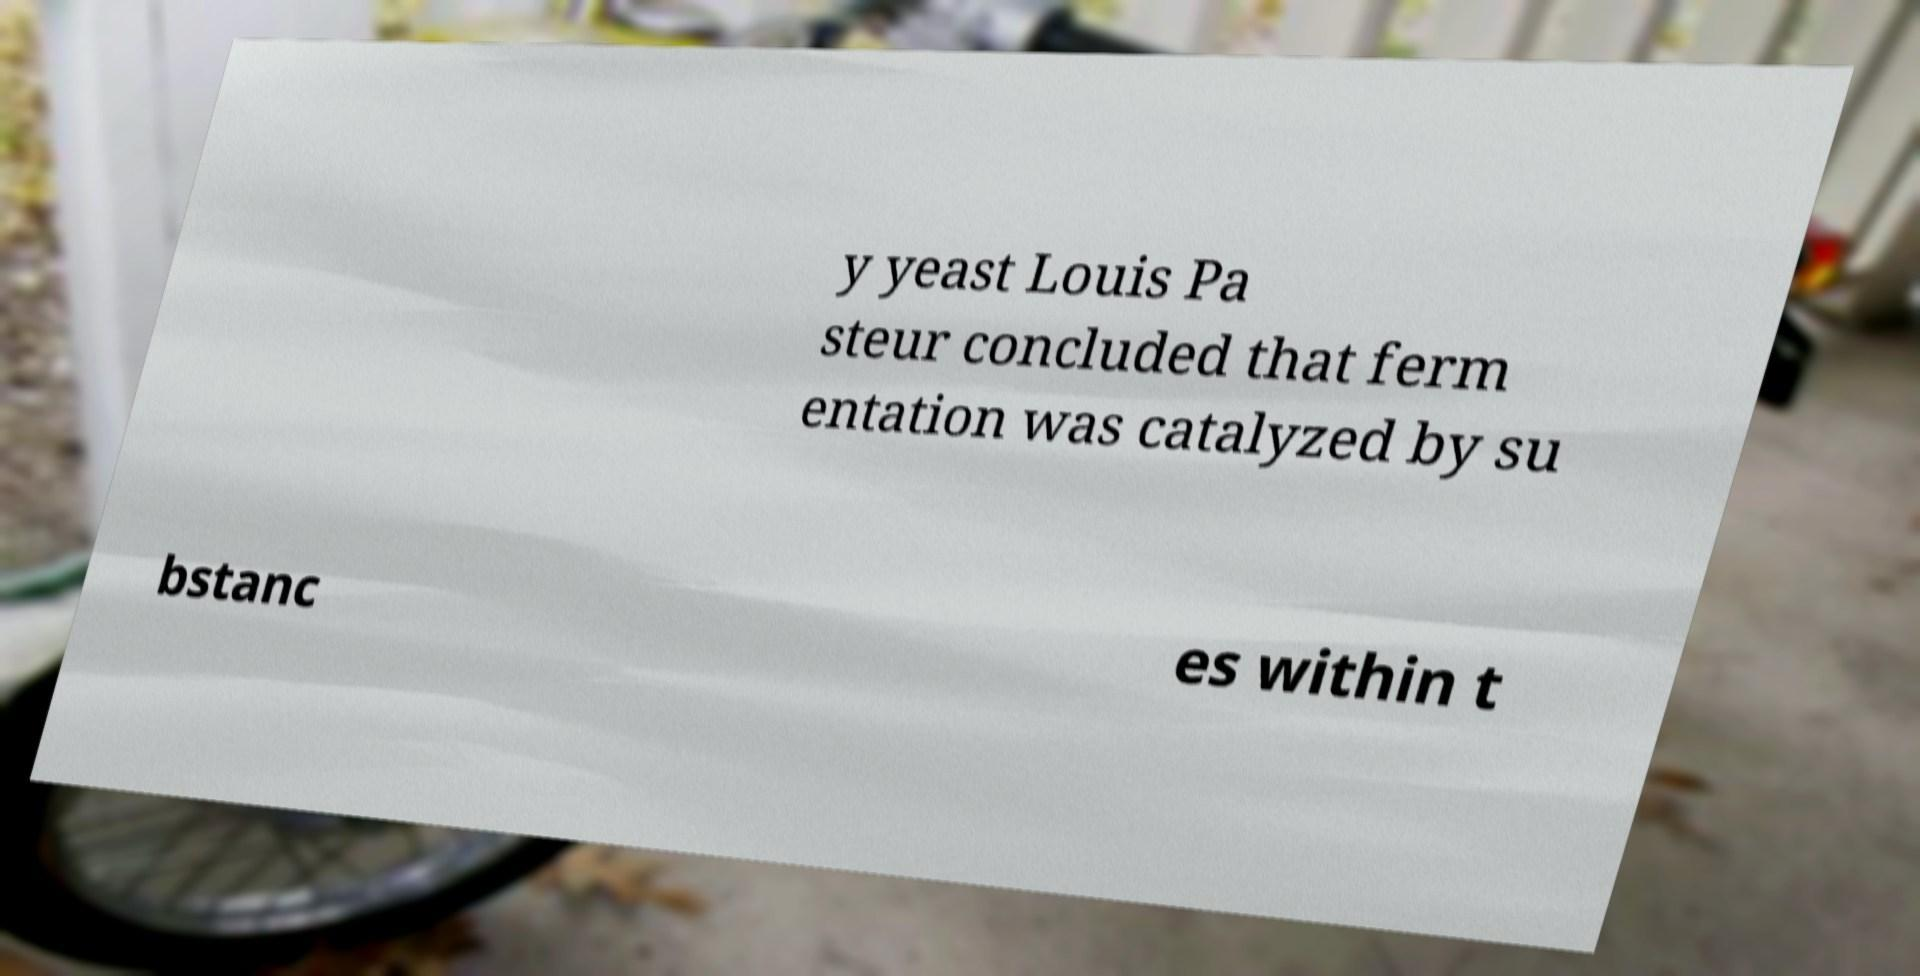Can you read and provide the text displayed in the image?This photo seems to have some interesting text. Can you extract and type it out for me? y yeast Louis Pa steur concluded that ferm entation was catalyzed by su bstanc es within t 